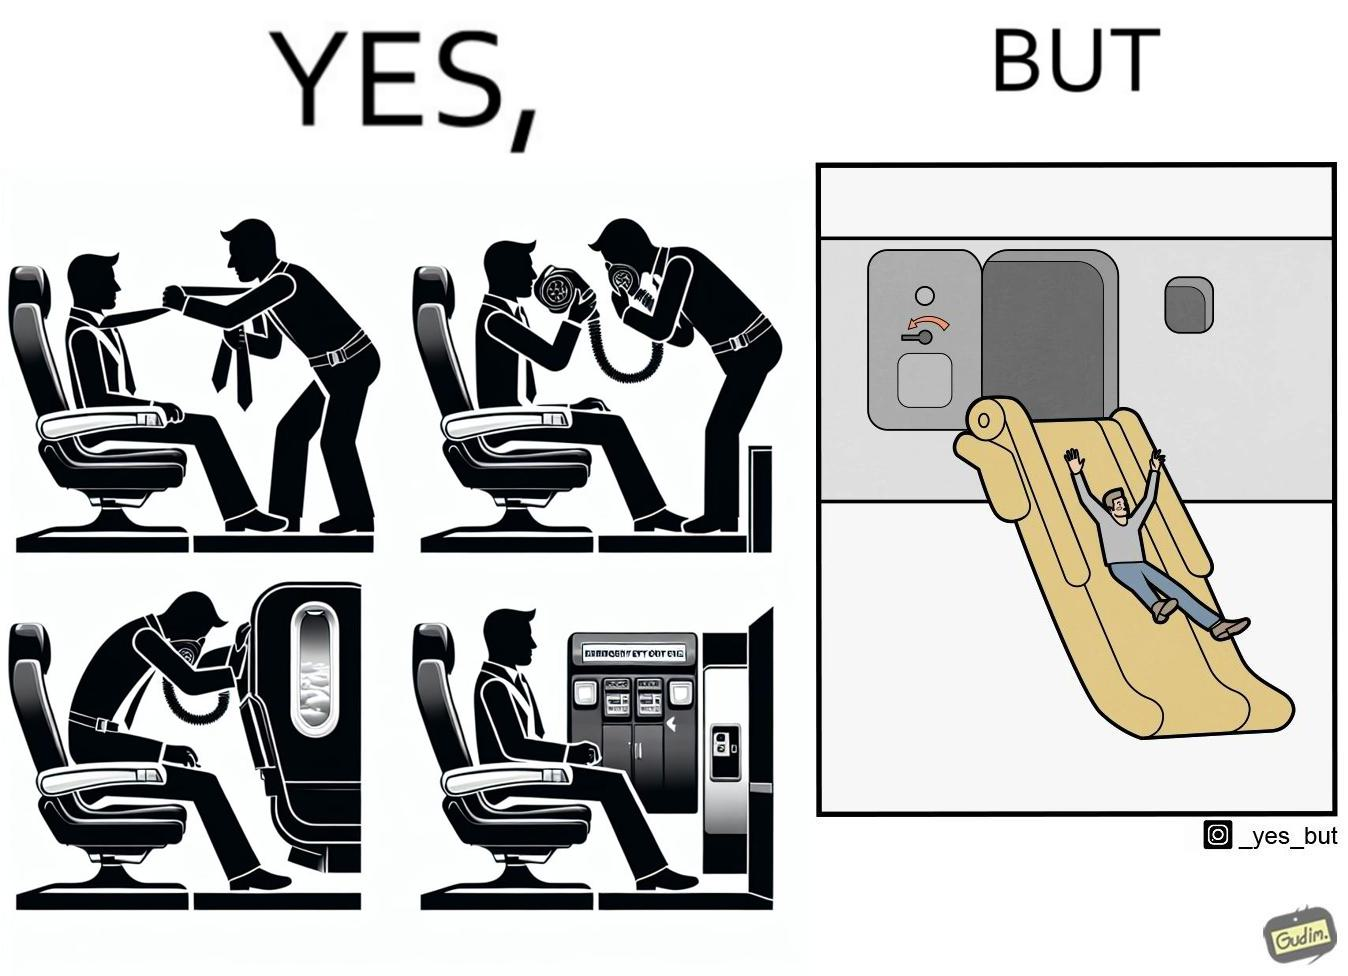Provide a description of this image. These images are funny since it shows how we are taught emergency procedures to follow in case of an accident while in an airplane but how none of them work if the plane is still in air 